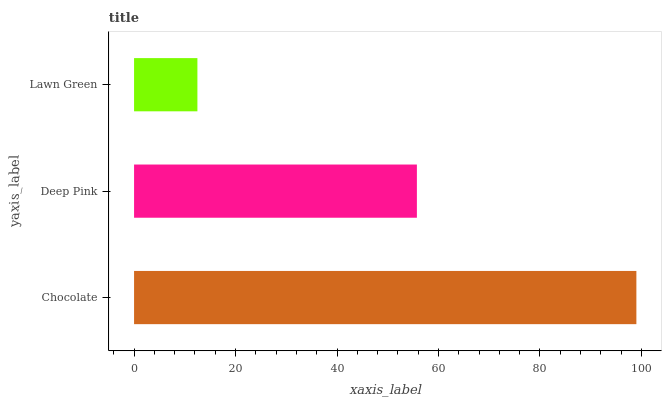Is Lawn Green the minimum?
Answer yes or no. Yes. Is Chocolate the maximum?
Answer yes or no. Yes. Is Deep Pink the minimum?
Answer yes or no. No. Is Deep Pink the maximum?
Answer yes or no. No. Is Chocolate greater than Deep Pink?
Answer yes or no. Yes. Is Deep Pink less than Chocolate?
Answer yes or no. Yes. Is Deep Pink greater than Chocolate?
Answer yes or no. No. Is Chocolate less than Deep Pink?
Answer yes or no. No. Is Deep Pink the high median?
Answer yes or no. Yes. Is Deep Pink the low median?
Answer yes or no. Yes. Is Chocolate the high median?
Answer yes or no. No. Is Chocolate the low median?
Answer yes or no. No. 